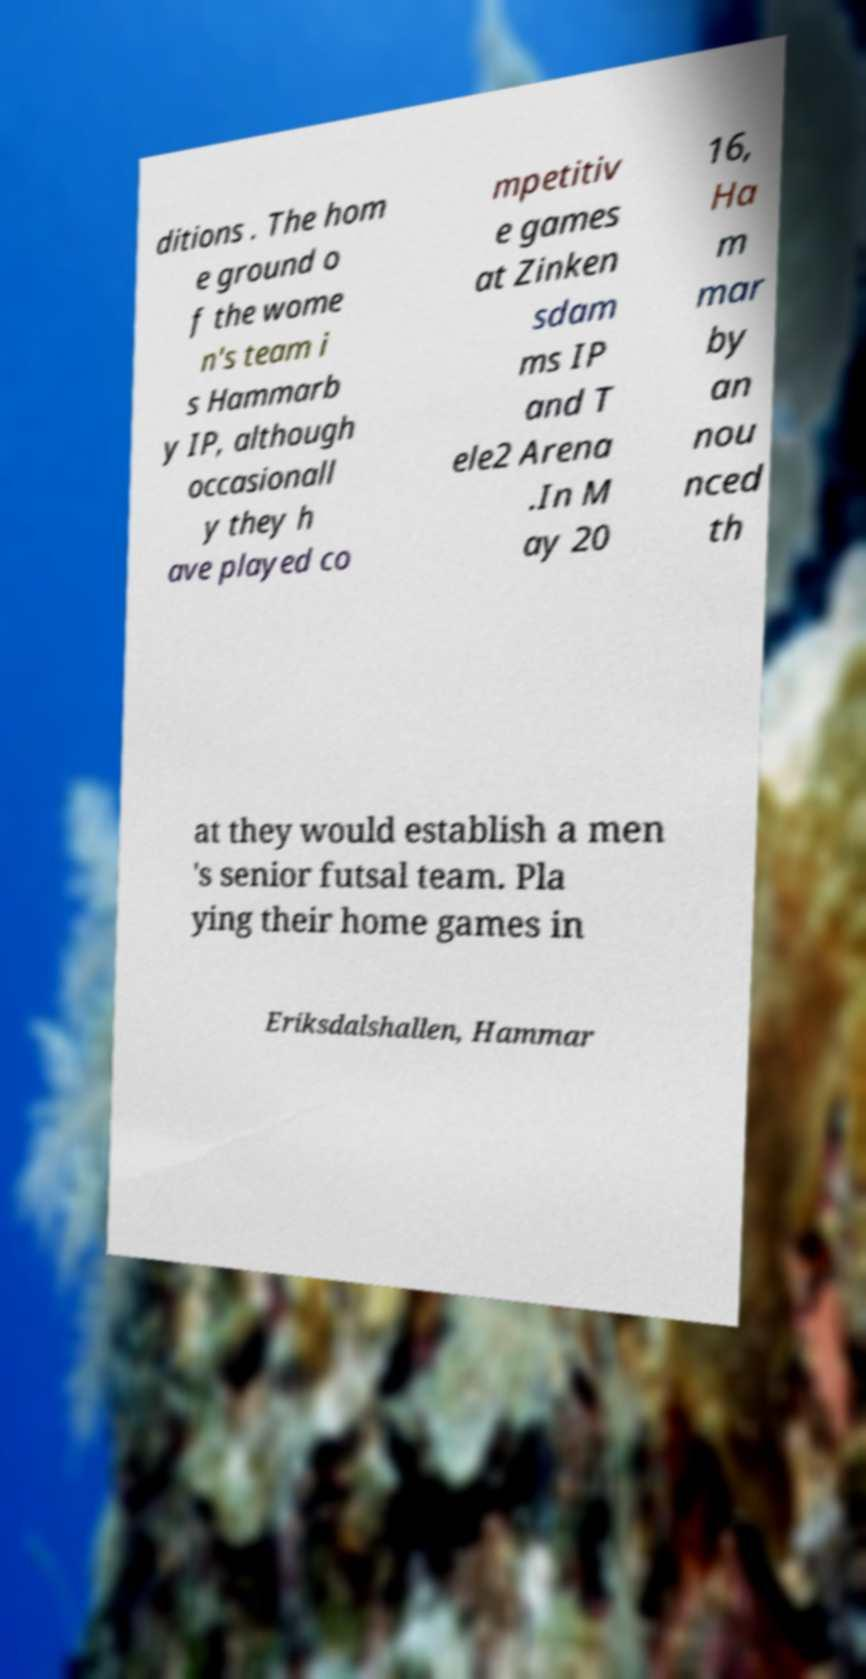There's text embedded in this image that I need extracted. Can you transcribe it verbatim? ditions . The hom e ground o f the wome n's team i s Hammarb y IP, although occasionall y they h ave played co mpetitiv e games at Zinken sdam ms IP and T ele2 Arena .In M ay 20 16, Ha m mar by an nou nced th at they would establish a men 's senior futsal team. Pla ying their home games in Eriksdalshallen, Hammar 